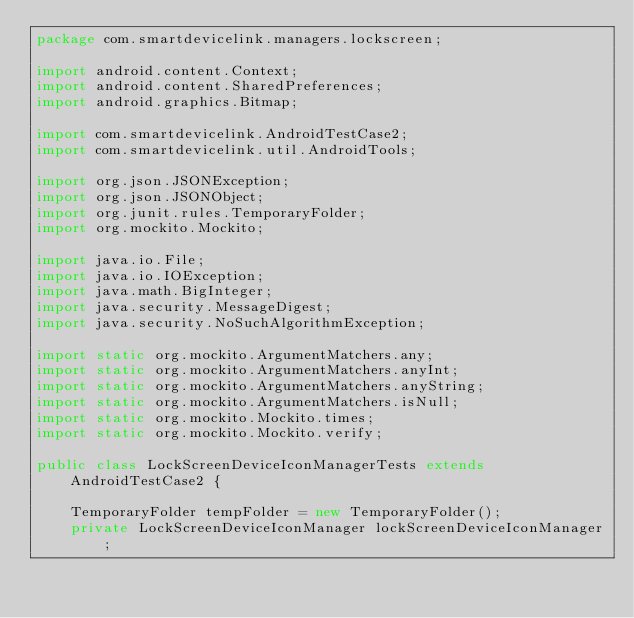<code> <loc_0><loc_0><loc_500><loc_500><_Java_>package com.smartdevicelink.managers.lockscreen;

import android.content.Context;
import android.content.SharedPreferences;
import android.graphics.Bitmap;

import com.smartdevicelink.AndroidTestCase2;
import com.smartdevicelink.util.AndroidTools;

import org.json.JSONException;
import org.json.JSONObject;
import org.junit.rules.TemporaryFolder;
import org.mockito.Mockito;

import java.io.File;
import java.io.IOException;
import java.math.BigInteger;
import java.security.MessageDigest;
import java.security.NoSuchAlgorithmException;

import static org.mockito.ArgumentMatchers.any;
import static org.mockito.ArgumentMatchers.anyInt;
import static org.mockito.ArgumentMatchers.anyString;
import static org.mockito.ArgumentMatchers.isNull;
import static org.mockito.Mockito.times;
import static org.mockito.Mockito.verify;

public class LockScreenDeviceIconManagerTests extends AndroidTestCase2 {

    TemporaryFolder tempFolder = new TemporaryFolder();
    private LockScreenDeviceIconManager lockScreenDeviceIconManager;</code> 